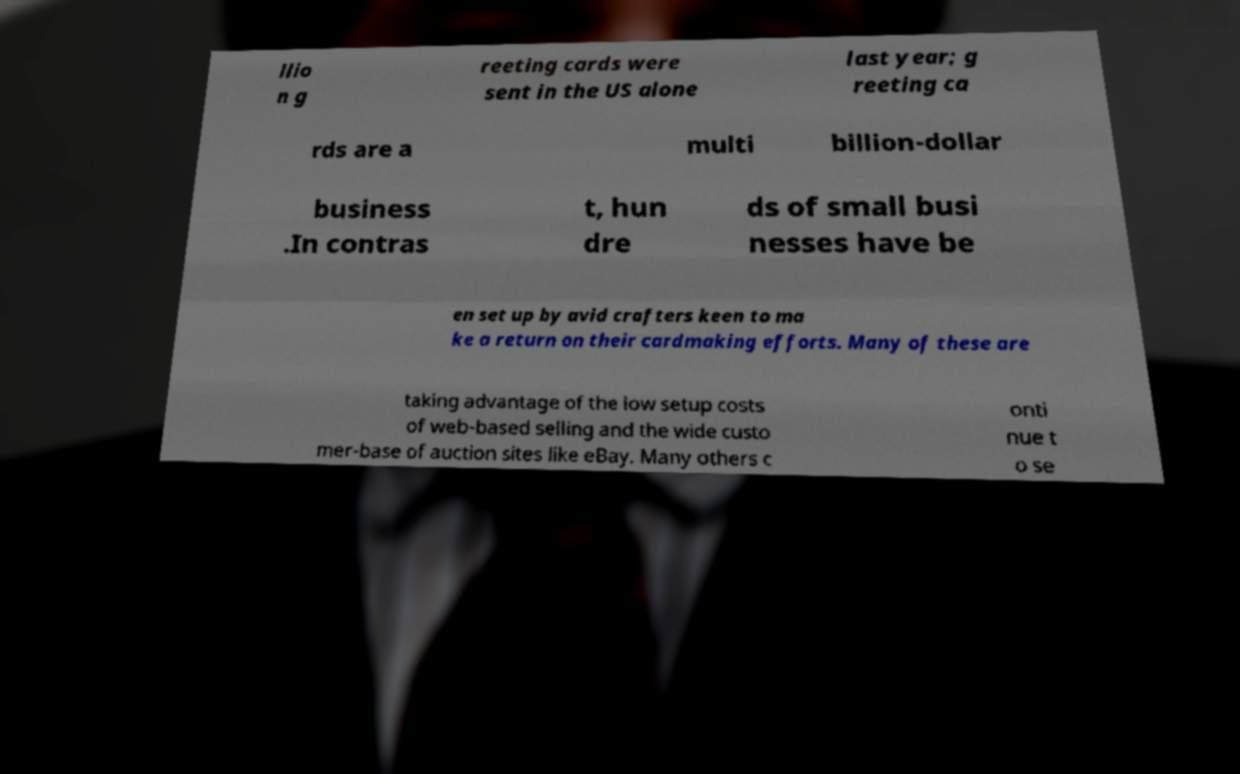Could you extract and type out the text from this image? llio n g reeting cards were sent in the US alone last year; g reeting ca rds are a multi billion-dollar business .In contras t, hun dre ds of small busi nesses have be en set up by avid crafters keen to ma ke a return on their cardmaking efforts. Many of these are taking advantage of the low setup costs of web-based selling and the wide custo mer-base of auction sites like eBay. Many others c onti nue t o se 